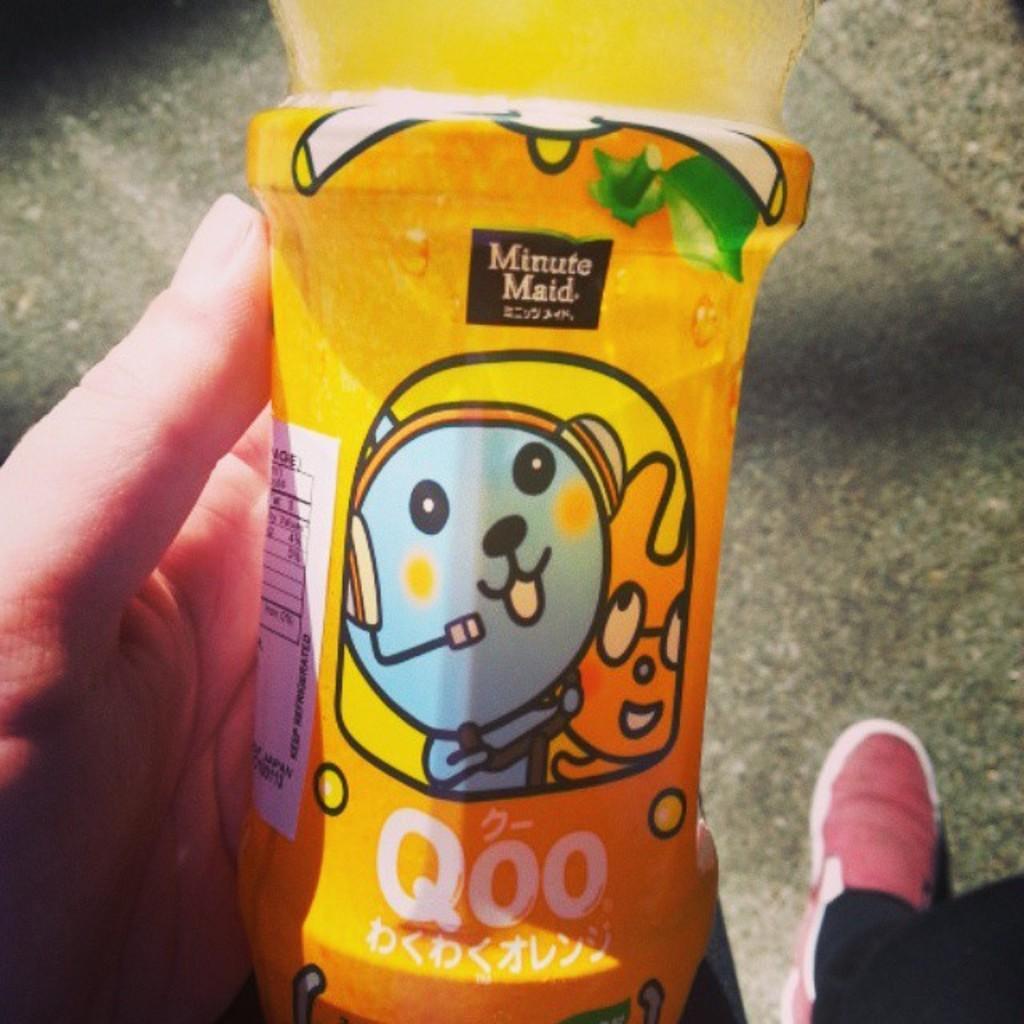How would you summarize this image in a sentence or two? We can see a person's hand and leg with shoe. On the hand there is a bottle with a label. On the label something is written. Also there is an image. 